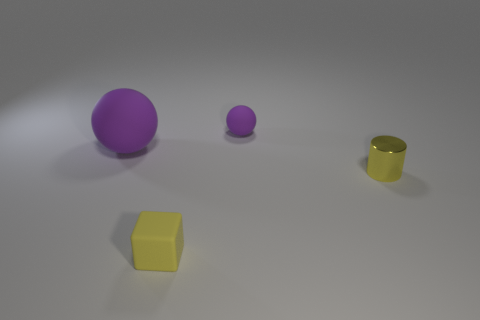Is there any object that stands out in some way, and can you explain why? The large purple sphere stands out due to its size being visibly larger than the other objects, and its bright color attracts attention amidst the more neutral background. 